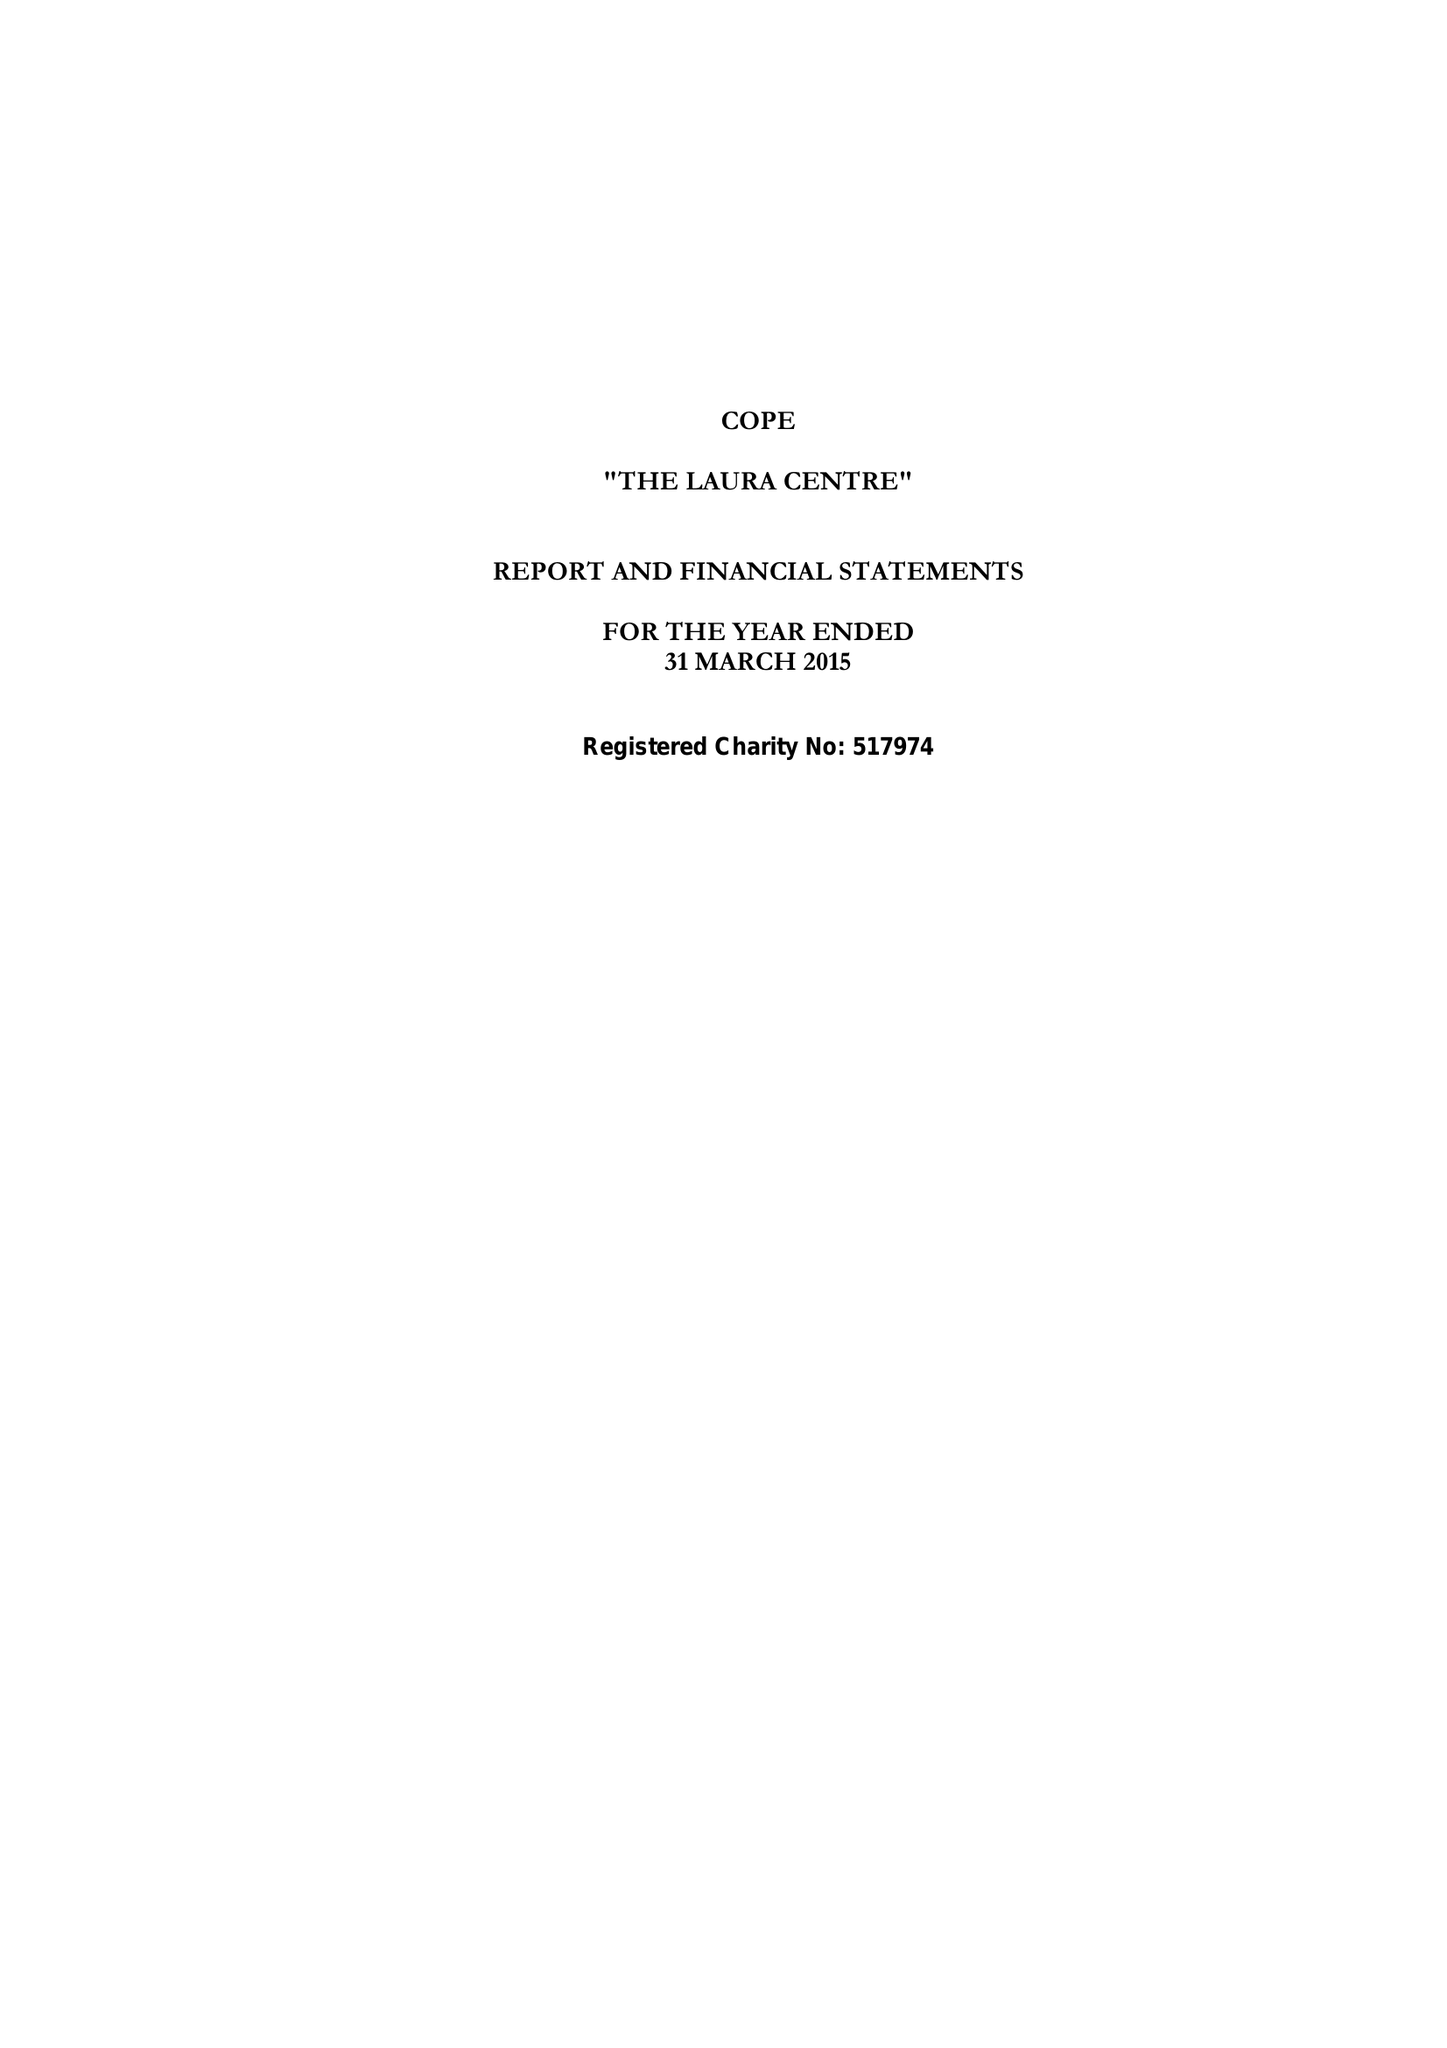What is the value for the address__post_town?
Answer the question using a single word or phrase. LEICESTER 